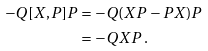Convert formula to latex. <formula><loc_0><loc_0><loc_500><loc_500>- Q [ X , P ] P & = - Q ( X P - P X ) P \\ & = - Q X P \, .</formula> 